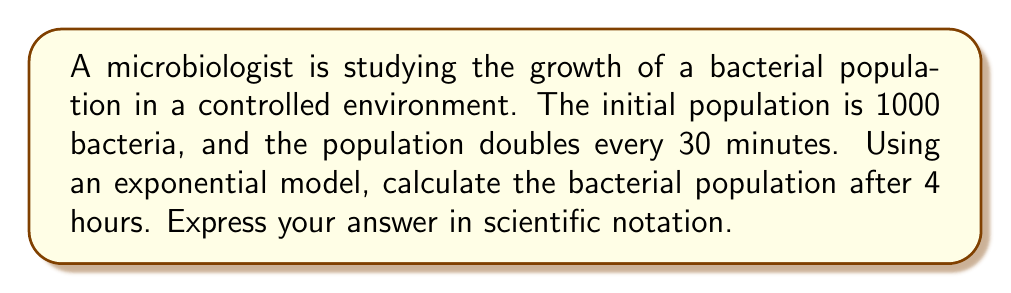Give your solution to this math problem. Let's approach this step-by-step:

1) First, we need to identify the components of our exponential model:
   - Initial population, $P_0 = 1000$
   - Growth rate: doubling every 30 minutes
   - Time: 4 hours

2) The general form of an exponential growth model is:

   $$ P(t) = P_0 \cdot b^t $$

   Where $P(t)$ is the population at time $t$, $P_0$ is the initial population, $b$ is the growth factor per unit time, and $t$ is the number of time units.

3) In this case, the population doubles every 30 minutes. So in 1 hour (our time unit), it doubles twice:

   $$ b = 2^2 = 4 $$

4) Now we can set up our equation:

   $$ P(4) = 1000 \cdot 4^4 $$

5) Let's calculate:

   $$ P(4) = 1000 \cdot 4^4 = 1000 \cdot 256 = 256,000 $$

6) To express this in scientific notation:

   $$ 256,000 = 2.56 \times 10^5 $$

This exponential growth model demonstrates the rapid proliferation capabilities of microorganisms, which is a fundamental concept in microbiology.
Answer: $2.56 \times 10^5$ bacteria 